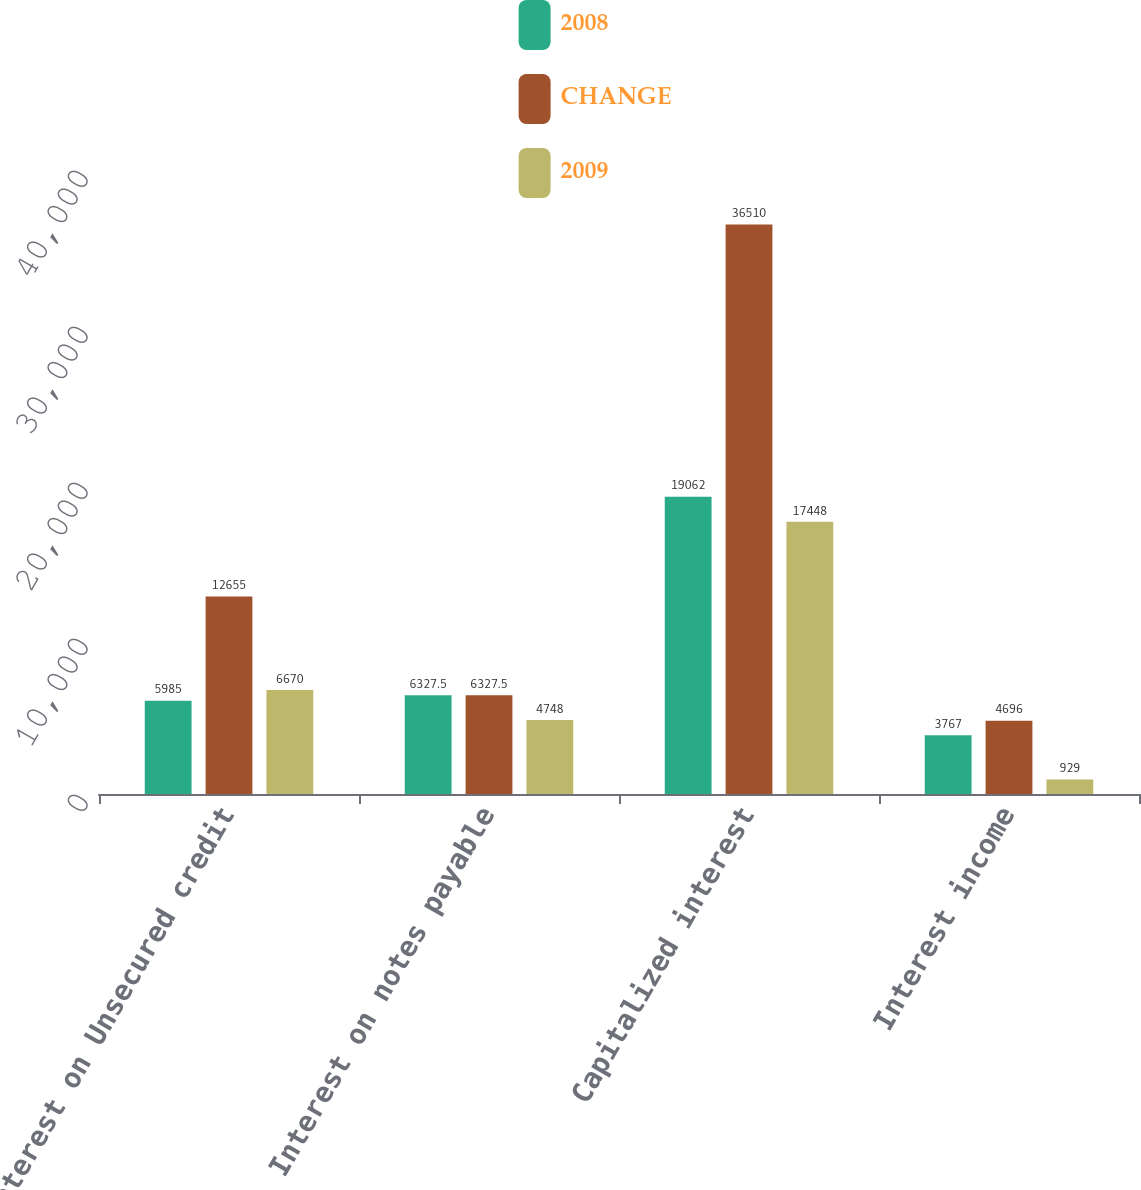<chart> <loc_0><loc_0><loc_500><loc_500><stacked_bar_chart><ecel><fcel>Interest on Unsecured credit<fcel>Interest on notes payable<fcel>Capitalized interest<fcel>Interest income<nl><fcel>2008<fcel>5985<fcel>6327.5<fcel>19062<fcel>3767<nl><fcel>CHANGE<fcel>12655<fcel>6327.5<fcel>36510<fcel>4696<nl><fcel>2009<fcel>6670<fcel>4748<fcel>17448<fcel>929<nl></chart> 